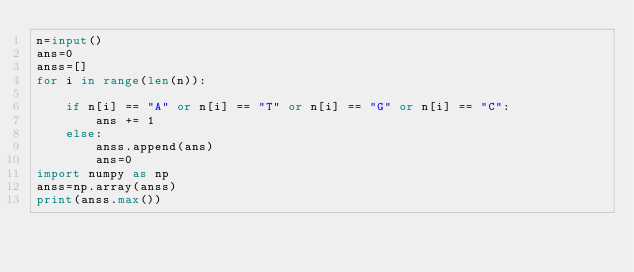<code> <loc_0><loc_0><loc_500><loc_500><_Python_>n=input()
ans=0
anss=[]
for i in range(len(n)):
    
    if n[i] == "A" or n[i] == "T" or n[i] == "G" or n[i] == "C":
        ans += 1
    else:
        anss.append(ans)
        ans=0
import numpy as np
anss=np.array(anss)
print(anss.max())</code> 